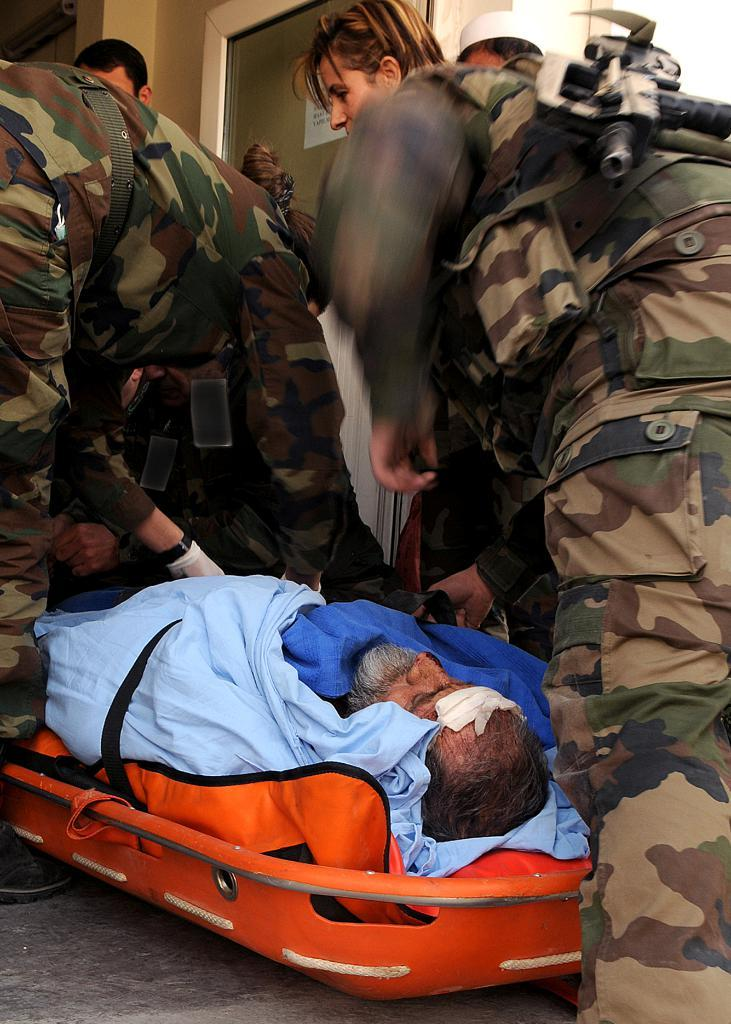How many people are in the image? There is a group of people in the image. What objects are present in the image that might be used as weapons? Guns are present in the image. What is the person on the bed doing? The person lying on a bed in the image is not doing any specific action that can be determined from the provided facts. What part of the room can be seen in the image? The floor is visible in the image. What architectural feature is present in the background of the image? There is a glass door in the background of the image. What decorative element is present in the background of the image? There is a sticker in the background of the image. What type of surface is present in the background of the image? There is a wall in the background of the image. What type of building is visible in the image? There is no building present in the image. What punishment is being administered to the person lying on the bed in the image? There is no indication of any punishment being administered to the person lying on the bed in the image. 